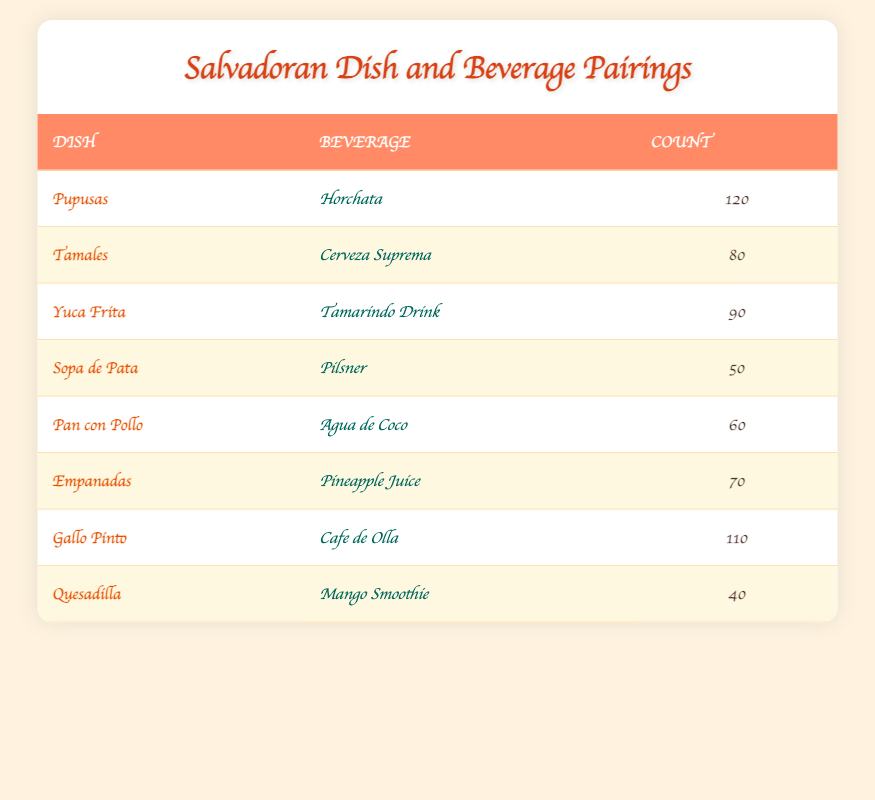What is the most commonly paired beverage with Pupusas? The table lists Pupusas alongside Horchata with a count of 120. This is the highest count for any beverage-dish pairing.
Answer: Horchata How many customers chose Gallo Pinto with Cafe de Olla? In the table, the count for Gallo Pinto paired with Cafe de Olla is 110, which is stated directly in the table.
Answer: 110 Which Salvadoran dish was paired with the least popular beverage? The Quesadilla is paired with a Mango Smoothie, which has the lowest count of 40 in the table.
Answer: Mango Smoothie If we consider the beverages only, what is the total count of customers for beverages listed in the table? To find the total count, I sum the counts: 120 + 80 + 90 + 50 + 60 + 70 + 110 + 40 = 620.
Answer: 620 Is it true that Sopa de Pata is paired with Cerveza Suprema? No, the table shows that Sopa de Pata is paired with Pilsner, not Cerveza Suprema.
Answer: No What is the difference in count between the most popular dish and the least popular dish? The most popular dish (Pupusas and Horchata) has a count of 120, and the least popular (Quesadilla and Mango Smoothie) has a count of 40. The difference is 120 - 40 = 80.
Answer: 80 How many dishes have a beverage count of 70 or more? The dishes with counts of 70 or more are Pupusas (120), Gallo Pinto (110), Yuca Frita (90), Tamales (80), and Empanadas (70), totaling 5 dishes.
Answer: 5 Which combination of dishes and beverages has the second-highest pairing count? The second-highest pairing is Gallo Pinto with Cafe de Olla, which has 110. The highest pairing was Pupusas with Horchata (120).
Answer: Gallo Pinto with Cafe de Olla What beverage is paired with the dish Pan con Pollo? According to the table, Pan con Pollo is paired with Agua de Coco. This information can be directly found in the table.
Answer: Agua de Coco 